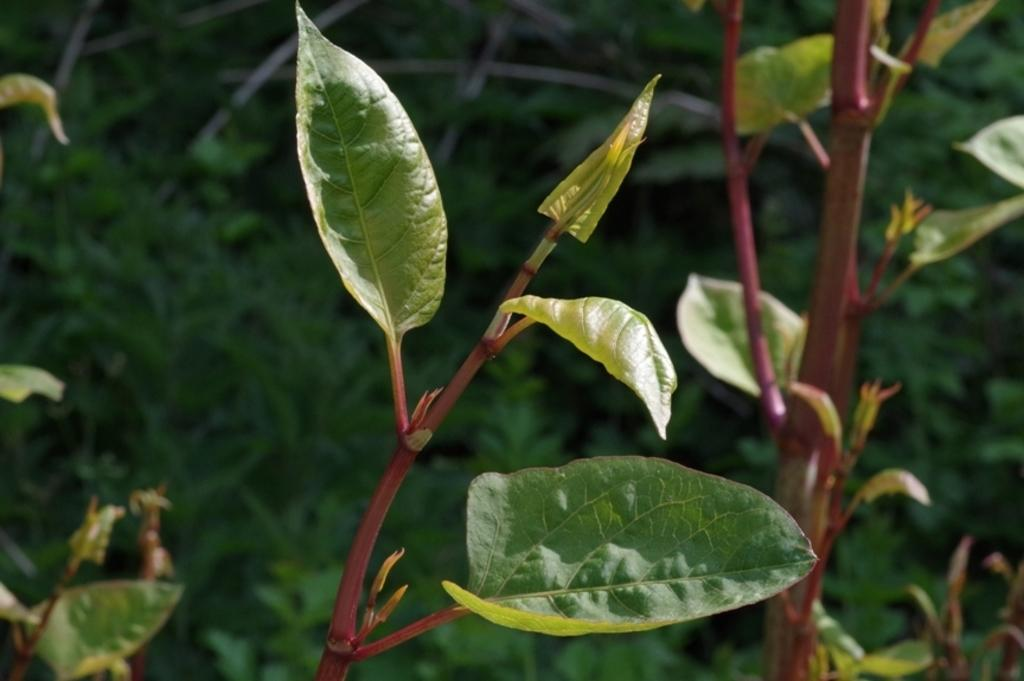What type of vegetation is present in the image? There are green leaves in the image. What color dominates the background of the image? The background of the image is green. What type of mint can be smelled in the image? There is no mention of mint or any scent in the image, so it cannot be determined from the image. 